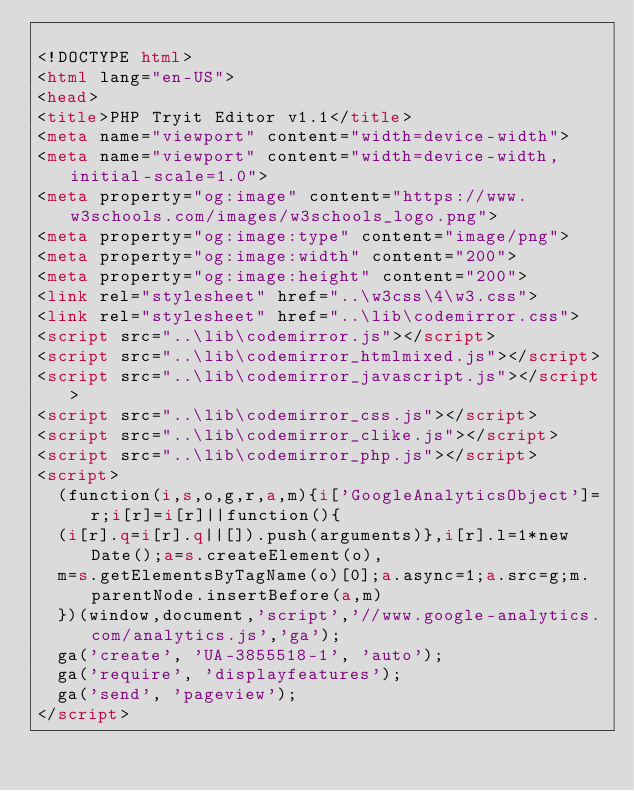Convert code to text. <code><loc_0><loc_0><loc_500><loc_500><_HTML_>
<!DOCTYPE html>
<html lang="en-US">
<head>
<title>PHP Tryit Editor v1.1</title>
<meta name="viewport" content="width=device-width">
<meta name="viewport" content="width=device-width, initial-scale=1.0">
<meta property="og:image" content="https://www.w3schools.com/images/w3schools_logo.png">
<meta property="og:image:type" content="image/png">
<meta property="og:image:width" content="200">
<meta property="og:image:height" content="200">
<link rel="stylesheet" href="..\w3css\4\w3.css">
<link rel="stylesheet" href="..\lib\codemirror.css">
<script src="..\lib\codemirror.js"></script>
<script src="..\lib\codemirror_htmlmixed.js"></script>
<script src="..\lib\codemirror_javascript.js"></script>
<script src="..\lib\codemirror_css.js"></script>
<script src="..\lib\codemirror_clike.js"></script>
<script src="..\lib\codemirror_php.js"></script>
<script>
  (function(i,s,o,g,r,a,m){i['GoogleAnalyticsObject']=r;i[r]=i[r]||function(){
  (i[r].q=i[r].q||[]).push(arguments)},i[r].l=1*new Date();a=s.createElement(o),
  m=s.getElementsByTagName(o)[0];a.async=1;a.src=g;m.parentNode.insertBefore(a,m)
  })(window,document,'script','//www.google-analytics.com/analytics.js','ga');
  ga('create', 'UA-3855518-1', 'auto');
  ga('require', 'displayfeatures');
  ga('send', 'pageview');
</script>
</code> 